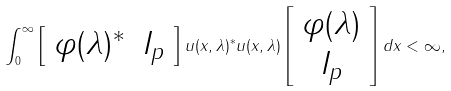<formula> <loc_0><loc_0><loc_500><loc_500>\int _ { 0 } ^ { \infty } \left [ \begin{array} { l r } \varphi ( \lambda ) ^ { * } & I _ { p } \end{array} \right ] u ( x , \lambda ) ^ { * } u ( x , \lambda ) \left [ \begin{array} { c } \varphi ( \lambda ) \\ I _ { p } \end{array} \right ] d x < \infty ,</formula> 